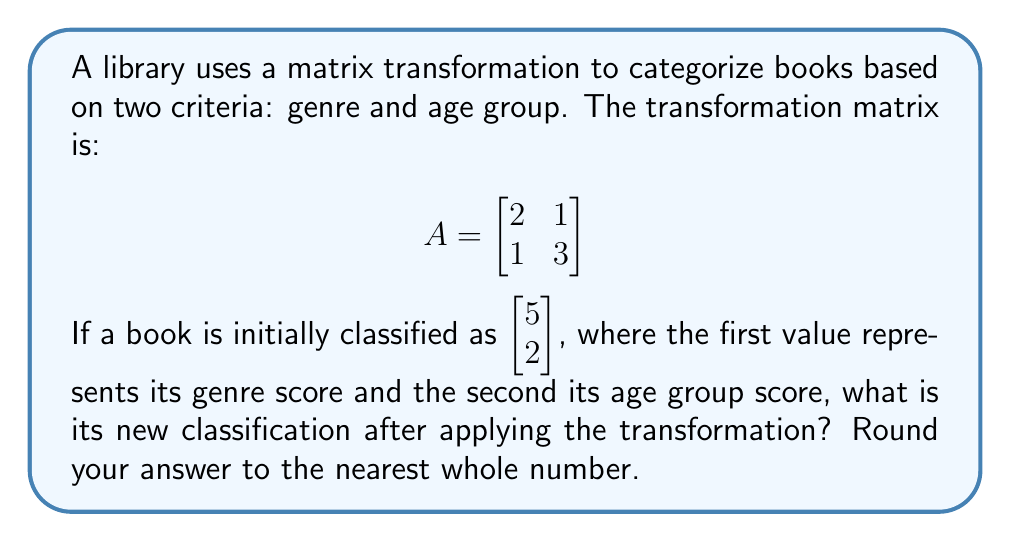Teach me how to tackle this problem. To solve this problem, we need to multiply the transformation matrix $A$ by the initial classification vector. Let's break it down step-by-step:

1) The initial classification vector is $\vec{v} = \begin{bmatrix} 5 \\ 2 \end{bmatrix}$

2) We need to calculate $A\vec{v}$:

   $$A\vec{v} = \begin{bmatrix} 
   2 & 1 \\
   1 & 3
   \end{bmatrix} \begin{bmatrix} 
   5 \\ 
   2
   \end{bmatrix}$$

3) Perform matrix multiplication:
   
   $$\begin{bmatrix} 
   (2 \cdot 5 + 1 \cdot 2) \\
   (1 \cdot 5 + 3 \cdot 2)
   \end{bmatrix}$$

4) Calculate the results:
   
   $$\begin{bmatrix} 
   (10 + 2) \\
   (5 + 6)
   \end{bmatrix} = \begin{bmatrix} 
   12 \\
   11
   \end{bmatrix}$$

5) As we're asked to round to the nearest whole number, our final answer doesn't change.

This new vector represents the book's updated classification after the transformation, with 12 as the new genre score and 11 as the new age group score.
Answer: $\begin{bmatrix} 
12 \\
11
\end{bmatrix}$ 